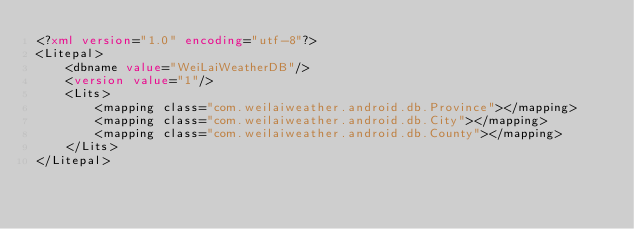Convert code to text. <code><loc_0><loc_0><loc_500><loc_500><_XML_><?xml version="1.0" encoding="utf-8"?>
<Litepal>
    <dbname value="WeiLaiWeatherDB"/>
    <version value="1"/>
    <Lits>
        <mapping class="com.weilaiweather.android.db.Province"></mapping>
        <mapping class="com.weilaiweather.android.db.City"></mapping>
        <mapping class="com.weilaiweather.android.db.County"></mapping>
    </Lits>
</Litepal></code> 